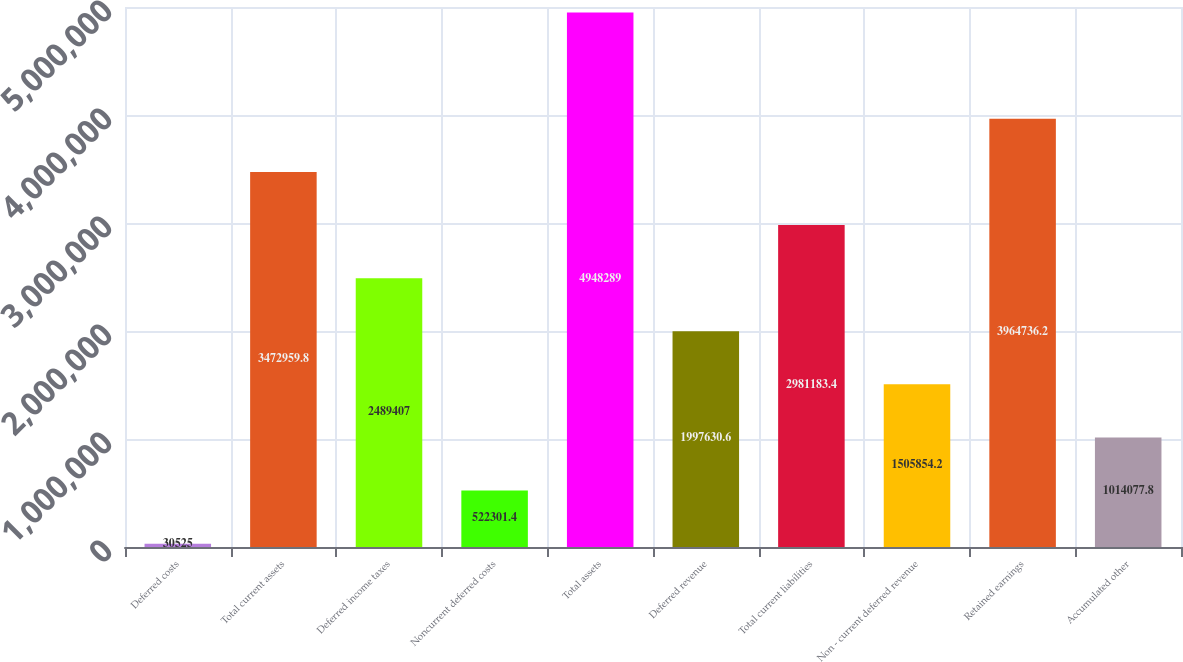<chart> <loc_0><loc_0><loc_500><loc_500><bar_chart><fcel>Deferred costs<fcel>Total current assets<fcel>Deferred income taxes<fcel>Noncurrent deferred costs<fcel>Total assets<fcel>Deferred revenue<fcel>Total current liabilities<fcel>Non - current deferred revenue<fcel>Retained earnings<fcel>Accumulated other<nl><fcel>30525<fcel>3.47296e+06<fcel>2.48941e+06<fcel>522301<fcel>4.94829e+06<fcel>1.99763e+06<fcel>2.98118e+06<fcel>1.50585e+06<fcel>3.96474e+06<fcel>1.01408e+06<nl></chart> 